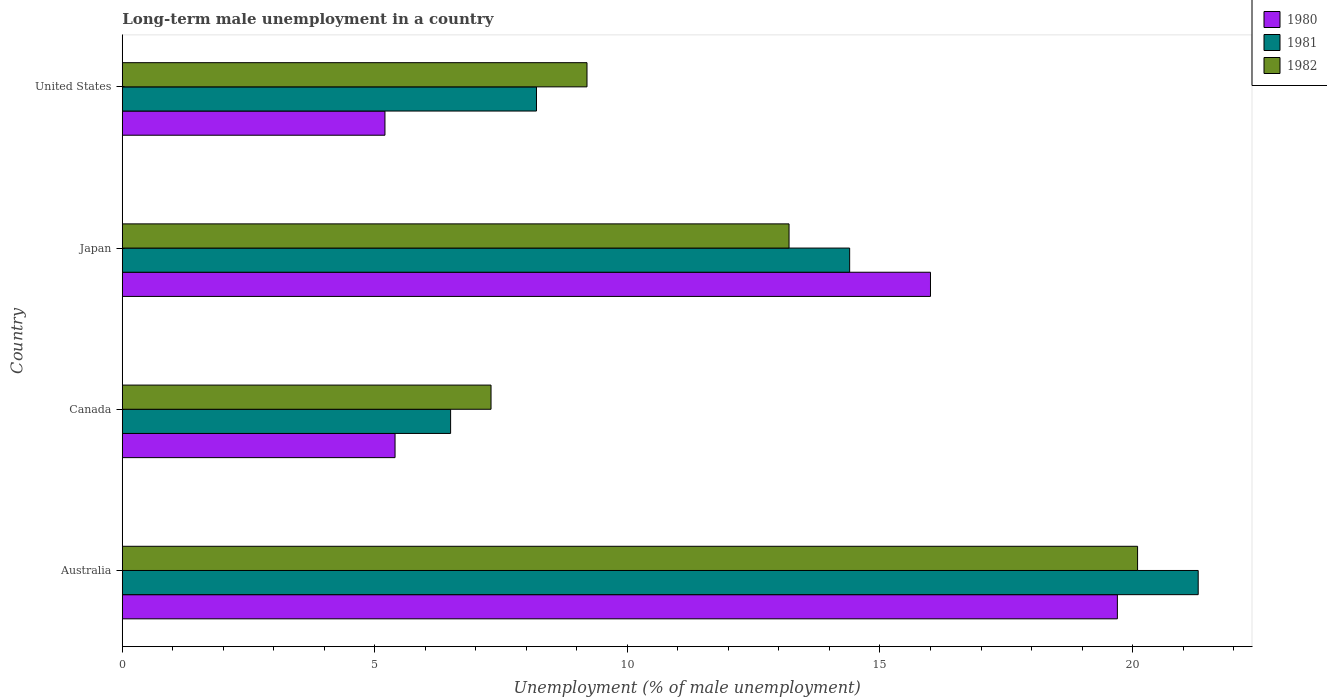How many groups of bars are there?
Ensure brevity in your answer.  4. What is the label of the 1st group of bars from the top?
Provide a succinct answer. United States. In how many cases, is the number of bars for a given country not equal to the number of legend labels?
Make the answer very short. 0. What is the percentage of long-term unemployed male population in 1982 in Canada?
Offer a very short reply. 7.3. Across all countries, what is the maximum percentage of long-term unemployed male population in 1980?
Your response must be concise. 19.7. Across all countries, what is the minimum percentage of long-term unemployed male population in 1980?
Provide a short and direct response. 5.2. What is the total percentage of long-term unemployed male population in 1980 in the graph?
Keep it short and to the point. 46.3. What is the difference between the percentage of long-term unemployed male population in 1982 in Australia and that in Canada?
Offer a very short reply. 12.8. What is the difference between the percentage of long-term unemployed male population in 1980 in Canada and the percentage of long-term unemployed male population in 1981 in United States?
Ensure brevity in your answer.  -2.8. What is the average percentage of long-term unemployed male population in 1981 per country?
Offer a terse response. 12.6. What is the difference between the percentage of long-term unemployed male population in 1981 and percentage of long-term unemployed male population in 1980 in United States?
Your response must be concise. 3. What is the ratio of the percentage of long-term unemployed male population in 1982 in Australia to that in United States?
Your answer should be compact. 2.18. Is the percentage of long-term unemployed male population in 1982 in Australia less than that in Japan?
Your answer should be very brief. No. What is the difference between the highest and the second highest percentage of long-term unemployed male population in 1982?
Ensure brevity in your answer.  6.9. What is the difference between the highest and the lowest percentage of long-term unemployed male population in 1982?
Keep it short and to the point. 12.8. In how many countries, is the percentage of long-term unemployed male population in 1981 greater than the average percentage of long-term unemployed male population in 1981 taken over all countries?
Offer a terse response. 2. Is the sum of the percentage of long-term unemployed male population in 1982 in Canada and United States greater than the maximum percentage of long-term unemployed male population in 1980 across all countries?
Ensure brevity in your answer.  No. What does the 3rd bar from the bottom in Canada represents?
Your answer should be compact. 1982. Is it the case that in every country, the sum of the percentage of long-term unemployed male population in 1980 and percentage of long-term unemployed male population in 1981 is greater than the percentage of long-term unemployed male population in 1982?
Your answer should be compact. Yes. How many bars are there?
Make the answer very short. 12. Are all the bars in the graph horizontal?
Keep it short and to the point. Yes. Are the values on the major ticks of X-axis written in scientific E-notation?
Provide a succinct answer. No. Does the graph contain any zero values?
Make the answer very short. No. Does the graph contain grids?
Provide a succinct answer. No. Where does the legend appear in the graph?
Give a very brief answer. Top right. How many legend labels are there?
Provide a succinct answer. 3. How are the legend labels stacked?
Your answer should be compact. Vertical. What is the title of the graph?
Ensure brevity in your answer.  Long-term male unemployment in a country. What is the label or title of the X-axis?
Provide a short and direct response. Unemployment (% of male unemployment). What is the Unemployment (% of male unemployment) in 1980 in Australia?
Your response must be concise. 19.7. What is the Unemployment (% of male unemployment) in 1981 in Australia?
Ensure brevity in your answer.  21.3. What is the Unemployment (% of male unemployment) in 1982 in Australia?
Keep it short and to the point. 20.1. What is the Unemployment (% of male unemployment) of 1980 in Canada?
Your answer should be compact. 5.4. What is the Unemployment (% of male unemployment) in 1981 in Canada?
Give a very brief answer. 6.5. What is the Unemployment (% of male unemployment) of 1982 in Canada?
Your response must be concise. 7.3. What is the Unemployment (% of male unemployment) of 1980 in Japan?
Your answer should be compact. 16. What is the Unemployment (% of male unemployment) of 1981 in Japan?
Your answer should be compact. 14.4. What is the Unemployment (% of male unemployment) in 1982 in Japan?
Give a very brief answer. 13.2. What is the Unemployment (% of male unemployment) of 1980 in United States?
Keep it short and to the point. 5.2. What is the Unemployment (% of male unemployment) of 1981 in United States?
Your answer should be compact. 8.2. What is the Unemployment (% of male unemployment) in 1982 in United States?
Give a very brief answer. 9.2. Across all countries, what is the maximum Unemployment (% of male unemployment) of 1980?
Ensure brevity in your answer.  19.7. Across all countries, what is the maximum Unemployment (% of male unemployment) in 1981?
Provide a short and direct response. 21.3. Across all countries, what is the maximum Unemployment (% of male unemployment) of 1982?
Offer a terse response. 20.1. Across all countries, what is the minimum Unemployment (% of male unemployment) in 1980?
Give a very brief answer. 5.2. Across all countries, what is the minimum Unemployment (% of male unemployment) of 1981?
Give a very brief answer. 6.5. Across all countries, what is the minimum Unemployment (% of male unemployment) in 1982?
Give a very brief answer. 7.3. What is the total Unemployment (% of male unemployment) in 1980 in the graph?
Your answer should be very brief. 46.3. What is the total Unemployment (% of male unemployment) of 1981 in the graph?
Provide a succinct answer. 50.4. What is the total Unemployment (% of male unemployment) of 1982 in the graph?
Keep it short and to the point. 49.8. What is the difference between the Unemployment (% of male unemployment) in 1980 in Australia and that in Canada?
Give a very brief answer. 14.3. What is the difference between the Unemployment (% of male unemployment) of 1981 in Australia and that in Canada?
Offer a terse response. 14.8. What is the difference between the Unemployment (% of male unemployment) of 1980 in Australia and that in United States?
Provide a short and direct response. 14.5. What is the difference between the Unemployment (% of male unemployment) in 1981 in Australia and that in United States?
Your answer should be very brief. 13.1. What is the difference between the Unemployment (% of male unemployment) in 1980 in Canada and that in United States?
Offer a terse response. 0.2. What is the difference between the Unemployment (% of male unemployment) in 1982 in Canada and that in United States?
Your answer should be compact. -1.9. What is the difference between the Unemployment (% of male unemployment) in 1980 in Japan and that in United States?
Make the answer very short. 10.8. What is the difference between the Unemployment (% of male unemployment) of 1981 in Japan and that in United States?
Make the answer very short. 6.2. What is the difference between the Unemployment (% of male unemployment) of 1982 in Japan and that in United States?
Your answer should be compact. 4. What is the difference between the Unemployment (% of male unemployment) in 1980 in Australia and the Unemployment (% of male unemployment) in 1981 in Canada?
Keep it short and to the point. 13.2. What is the difference between the Unemployment (% of male unemployment) in 1980 in Australia and the Unemployment (% of male unemployment) in 1981 in Japan?
Your answer should be very brief. 5.3. What is the difference between the Unemployment (% of male unemployment) of 1980 in Australia and the Unemployment (% of male unemployment) of 1982 in Japan?
Your response must be concise. 6.5. What is the difference between the Unemployment (% of male unemployment) of 1981 in Australia and the Unemployment (% of male unemployment) of 1982 in Japan?
Provide a short and direct response. 8.1. What is the difference between the Unemployment (% of male unemployment) of 1981 in Australia and the Unemployment (% of male unemployment) of 1982 in United States?
Ensure brevity in your answer.  12.1. What is the difference between the Unemployment (% of male unemployment) in 1981 in Canada and the Unemployment (% of male unemployment) in 1982 in United States?
Your answer should be compact. -2.7. What is the difference between the Unemployment (% of male unemployment) of 1981 in Japan and the Unemployment (% of male unemployment) of 1982 in United States?
Offer a terse response. 5.2. What is the average Unemployment (% of male unemployment) in 1980 per country?
Ensure brevity in your answer.  11.57. What is the average Unemployment (% of male unemployment) of 1981 per country?
Your answer should be very brief. 12.6. What is the average Unemployment (% of male unemployment) in 1982 per country?
Ensure brevity in your answer.  12.45. What is the difference between the Unemployment (% of male unemployment) in 1980 and Unemployment (% of male unemployment) in 1981 in Australia?
Ensure brevity in your answer.  -1.6. What is the difference between the Unemployment (% of male unemployment) in 1980 and Unemployment (% of male unemployment) in 1982 in Australia?
Provide a short and direct response. -0.4. What is the difference between the Unemployment (% of male unemployment) of 1981 and Unemployment (% of male unemployment) of 1982 in Australia?
Provide a succinct answer. 1.2. What is the difference between the Unemployment (% of male unemployment) of 1980 and Unemployment (% of male unemployment) of 1981 in Canada?
Give a very brief answer. -1.1. What is the difference between the Unemployment (% of male unemployment) of 1981 and Unemployment (% of male unemployment) of 1982 in Canada?
Provide a short and direct response. -0.8. What is the difference between the Unemployment (% of male unemployment) in 1980 and Unemployment (% of male unemployment) in 1982 in Japan?
Offer a terse response. 2.8. What is the difference between the Unemployment (% of male unemployment) of 1981 and Unemployment (% of male unemployment) of 1982 in Japan?
Your response must be concise. 1.2. What is the difference between the Unemployment (% of male unemployment) of 1980 and Unemployment (% of male unemployment) of 1982 in United States?
Make the answer very short. -4. What is the difference between the Unemployment (% of male unemployment) of 1981 and Unemployment (% of male unemployment) of 1982 in United States?
Offer a terse response. -1. What is the ratio of the Unemployment (% of male unemployment) of 1980 in Australia to that in Canada?
Your answer should be very brief. 3.65. What is the ratio of the Unemployment (% of male unemployment) in 1981 in Australia to that in Canada?
Offer a very short reply. 3.28. What is the ratio of the Unemployment (% of male unemployment) in 1982 in Australia to that in Canada?
Your answer should be very brief. 2.75. What is the ratio of the Unemployment (% of male unemployment) of 1980 in Australia to that in Japan?
Your response must be concise. 1.23. What is the ratio of the Unemployment (% of male unemployment) of 1981 in Australia to that in Japan?
Offer a very short reply. 1.48. What is the ratio of the Unemployment (% of male unemployment) of 1982 in Australia to that in Japan?
Give a very brief answer. 1.52. What is the ratio of the Unemployment (% of male unemployment) of 1980 in Australia to that in United States?
Ensure brevity in your answer.  3.79. What is the ratio of the Unemployment (% of male unemployment) of 1981 in Australia to that in United States?
Your answer should be very brief. 2.6. What is the ratio of the Unemployment (% of male unemployment) in 1982 in Australia to that in United States?
Your answer should be very brief. 2.18. What is the ratio of the Unemployment (% of male unemployment) of 1980 in Canada to that in Japan?
Provide a short and direct response. 0.34. What is the ratio of the Unemployment (% of male unemployment) of 1981 in Canada to that in Japan?
Make the answer very short. 0.45. What is the ratio of the Unemployment (% of male unemployment) in 1982 in Canada to that in Japan?
Your response must be concise. 0.55. What is the ratio of the Unemployment (% of male unemployment) of 1981 in Canada to that in United States?
Offer a very short reply. 0.79. What is the ratio of the Unemployment (% of male unemployment) of 1982 in Canada to that in United States?
Offer a very short reply. 0.79. What is the ratio of the Unemployment (% of male unemployment) of 1980 in Japan to that in United States?
Offer a terse response. 3.08. What is the ratio of the Unemployment (% of male unemployment) in 1981 in Japan to that in United States?
Your answer should be compact. 1.76. What is the ratio of the Unemployment (% of male unemployment) of 1982 in Japan to that in United States?
Make the answer very short. 1.43. What is the difference between the highest and the second highest Unemployment (% of male unemployment) in 1981?
Ensure brevity in your answer.  6.9. What is the difference between the highest and the lowest Unemployment (% of male unemployment) of 1980?
Your answer should be very brief. 14.5. What is the difference between the highest and the lowest Unemployment (% of male unemployment) of 1981?
Your response must be concise. 14.8. What is the difference between the highest and the lowest Unemployment (% of male unemployment) in 1982?
Keep it short and to the point. 12.8. 